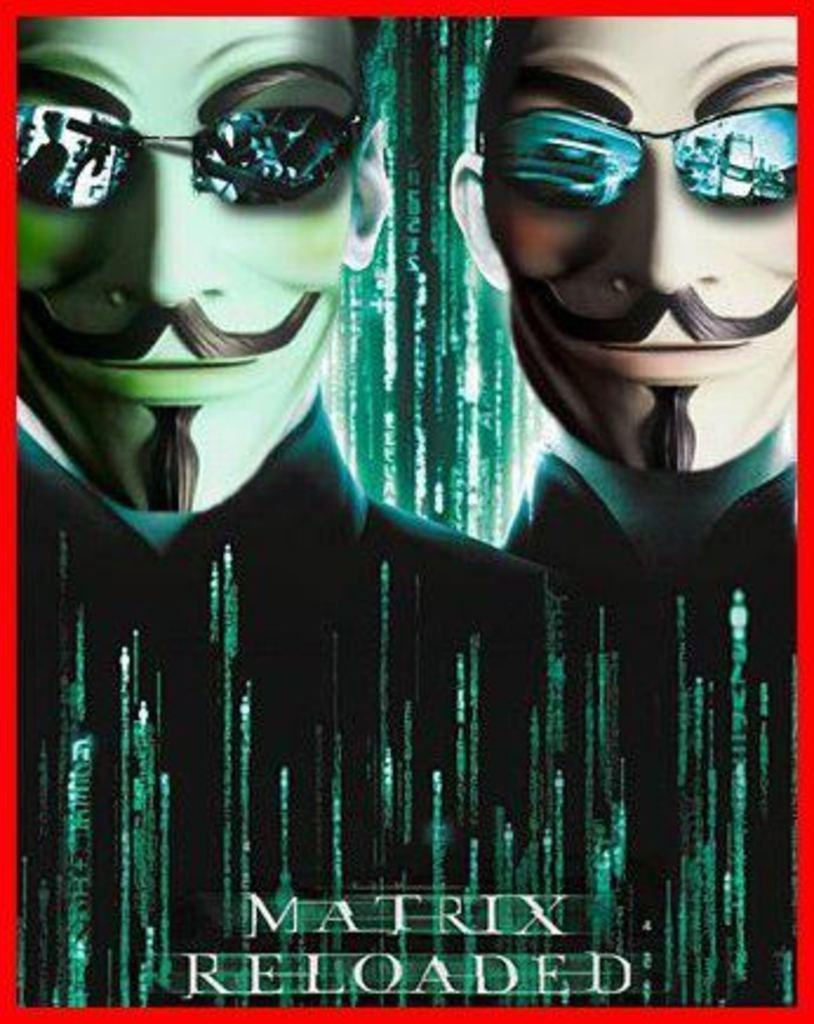Please provide a concise description of this image. This image consists of a poster. In which there are pictures of two men. At the bottom, there is a text. The poster border is in red color. 